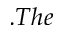<formula> <loc_0><loc_0><loc_500><loc_500>. T h e</formula> 